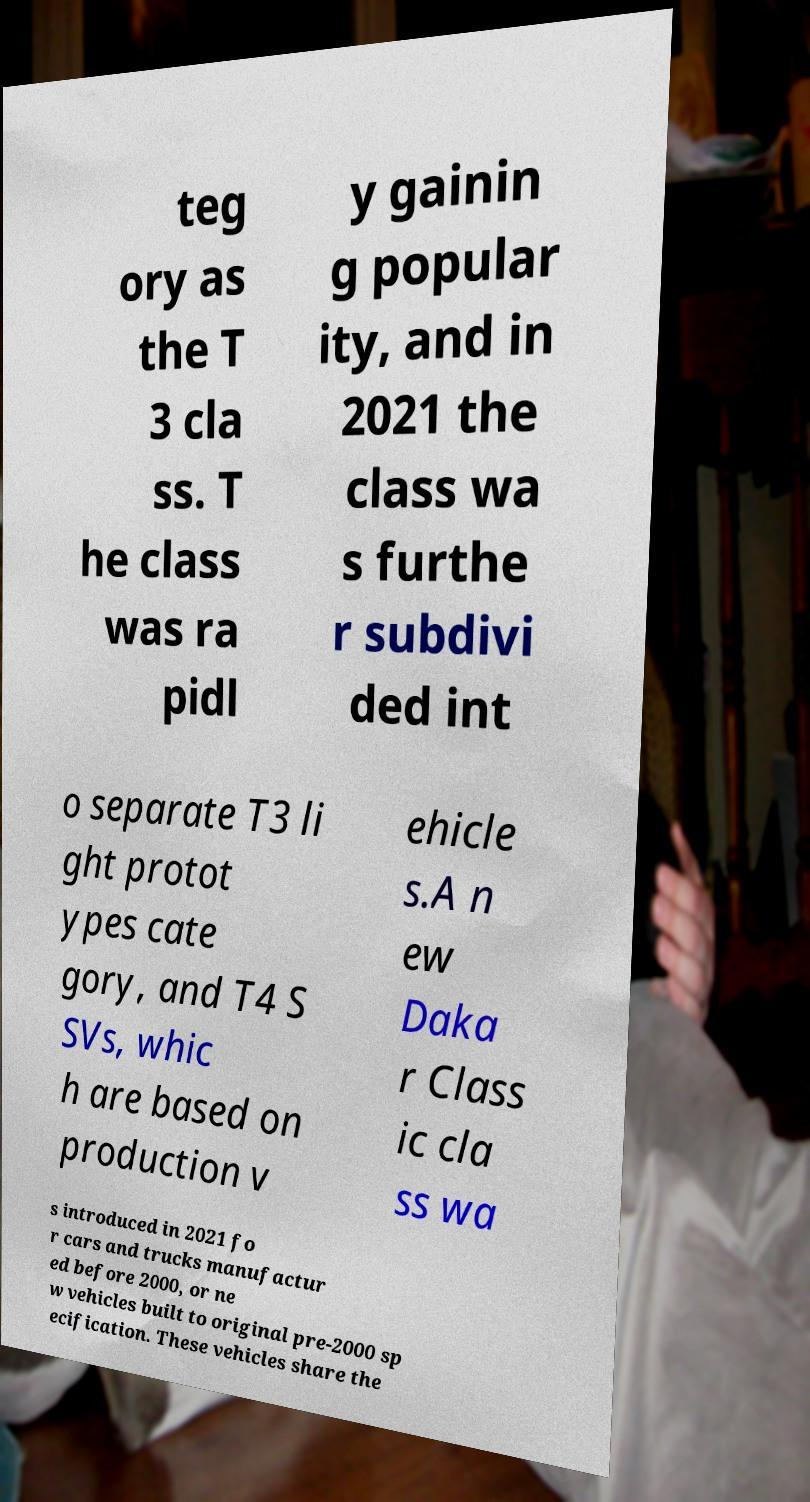Please read and relay the text visible in this image. What does it say? teg ory as the T 3 cla ss. T he class was ra pidl y gainin g popular ity, and in 2021 the class wa s furthe r subdivi ded int o separate T3 li ght protot ypes cate gory, and T4 S SVs, whic h are based on production v ehicle s.A n ew Daka r Class ic cla ss wa s introduced in 2021 fo r cars and trucks manufactur ed before 2000, or ne w vehicles built to original pre-2000 sp ecification. These vehicles share the 